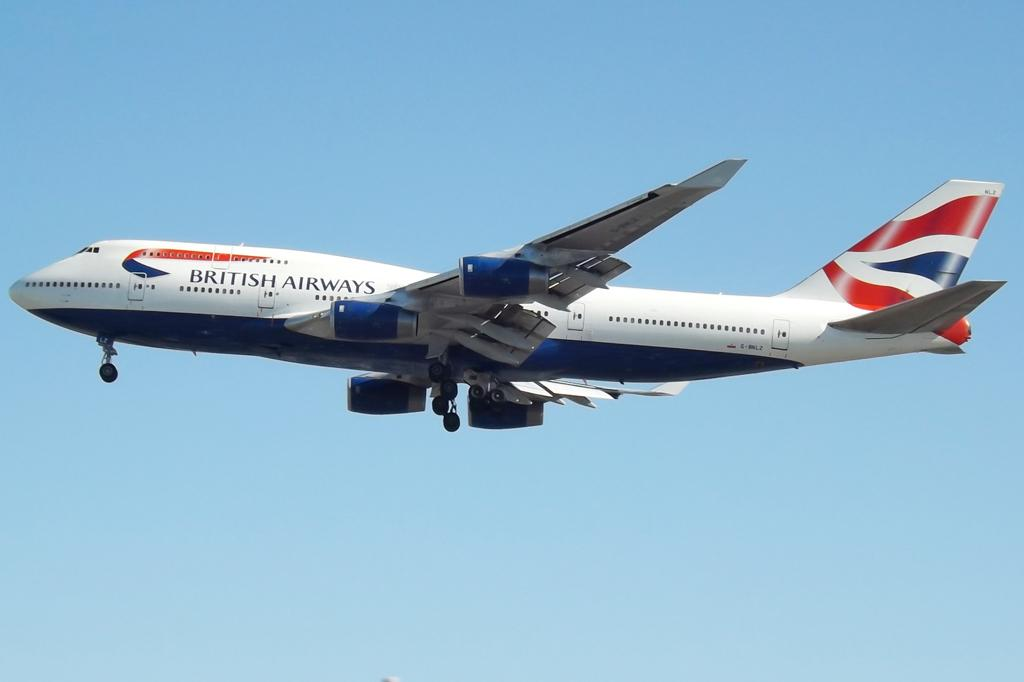<image>
Present a compact description of the photo's key features. british airways plane with the landing gears down 